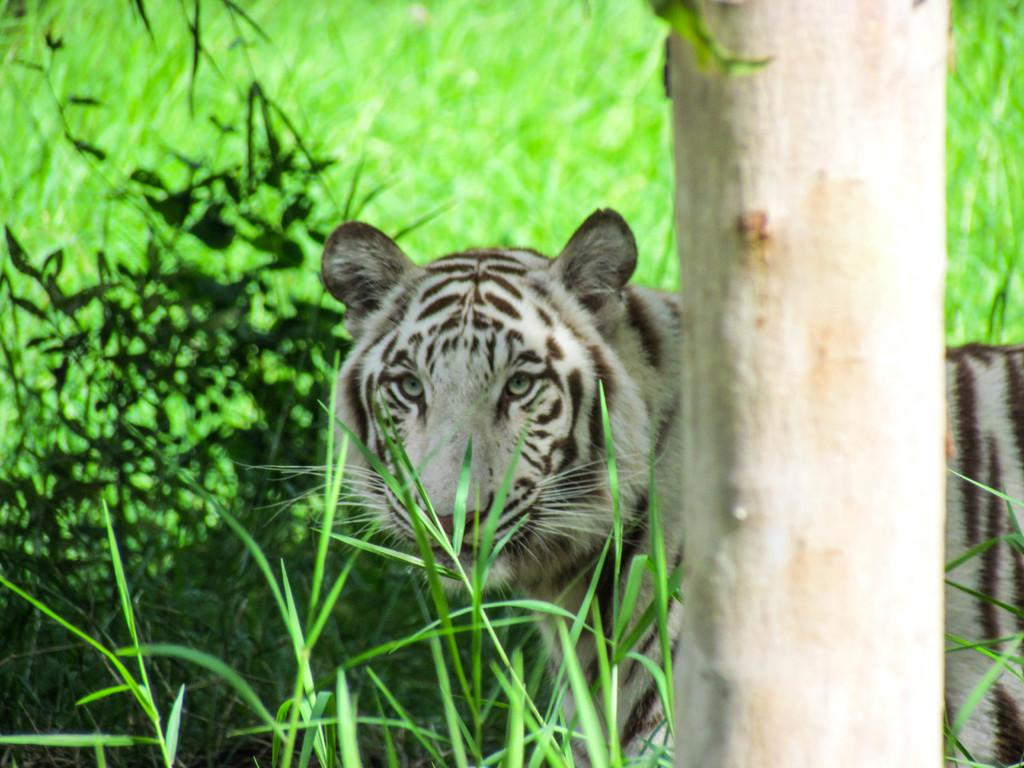What type of animal is in the image? There is a tiger in the image. What object can be seen in the image besides the tiger? There is a wooden stick in the image. What type of vegetation is present in the image? There are plants and grass in the image. What type of furniture is being used to teach the tiger in the image? There is no furniture or teaching activity present in the image; it features a tiger, a wooden stick, plants, and grass. 